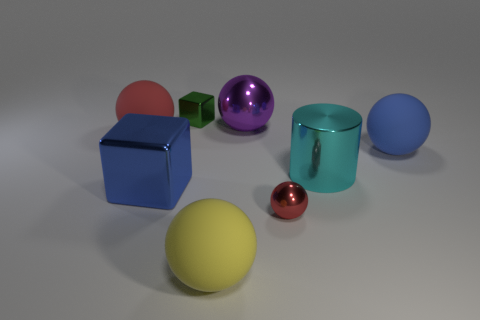Subtract all large metallic spheres. How many spheres are left? 4 Subtract all blue blocks. How many blocks are left? 1 Subtract all red cylinders. How many red balls are left? 2 Add 1 tiny cyan shiny blocks. How many objects exist? 9 Subtract all spheres. How many objects are left? 3 Subtract 3 balls. How many balls are left? 2 Subtract all blue rubber cubes. Subtract all big blue matte things. How many objects are left? 7 Add 7 big shiny cylinders. How many big shiny cylinders are left? 8 Add 8 big yellow matte things. How many big yellow matte things exist? 9 Subtract 1 green blocks. How many objects are left? 7 